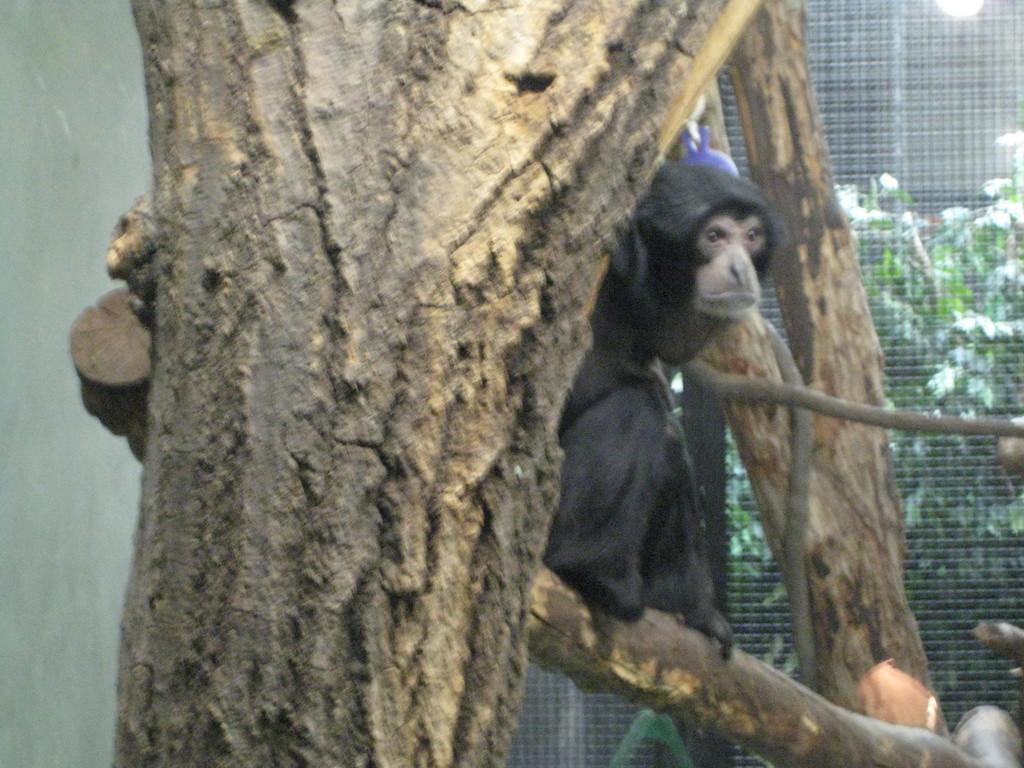Can you describe this image briefly? We can see animal sitting on a branch and tree trunks. We can see wall and mesh,behind this mess we can see plants. We can see light. 